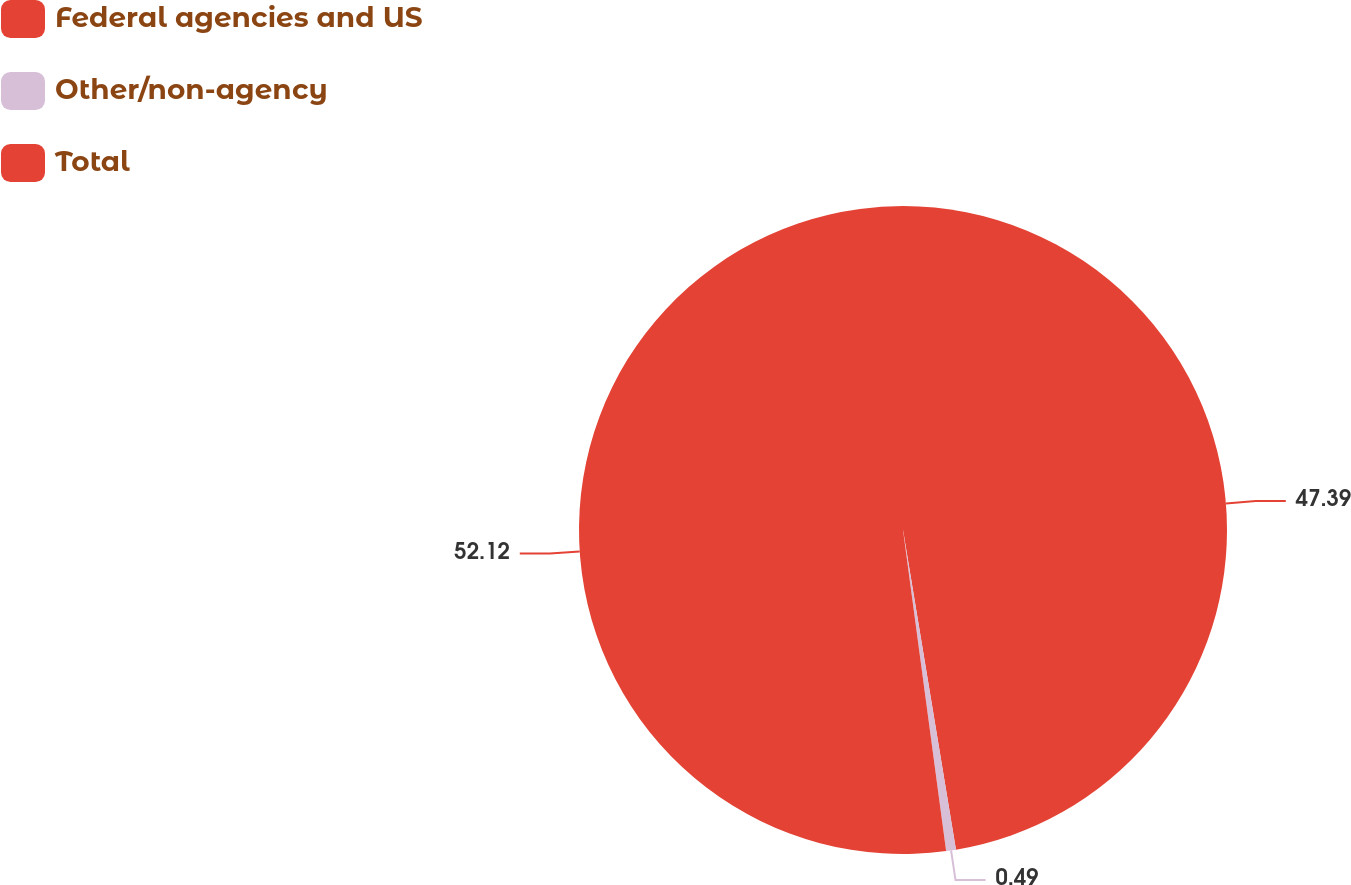Convert chart to OTSL. <chart><loc_0><loc_0><loc_500><loc_500><pie_chart><fcel>Federal agencies and US<fcel>Other/non-agency<fcel>Total<nl><fcel>47.39%<fcel>0.49%<fcel>52.13%<nl></chart> 